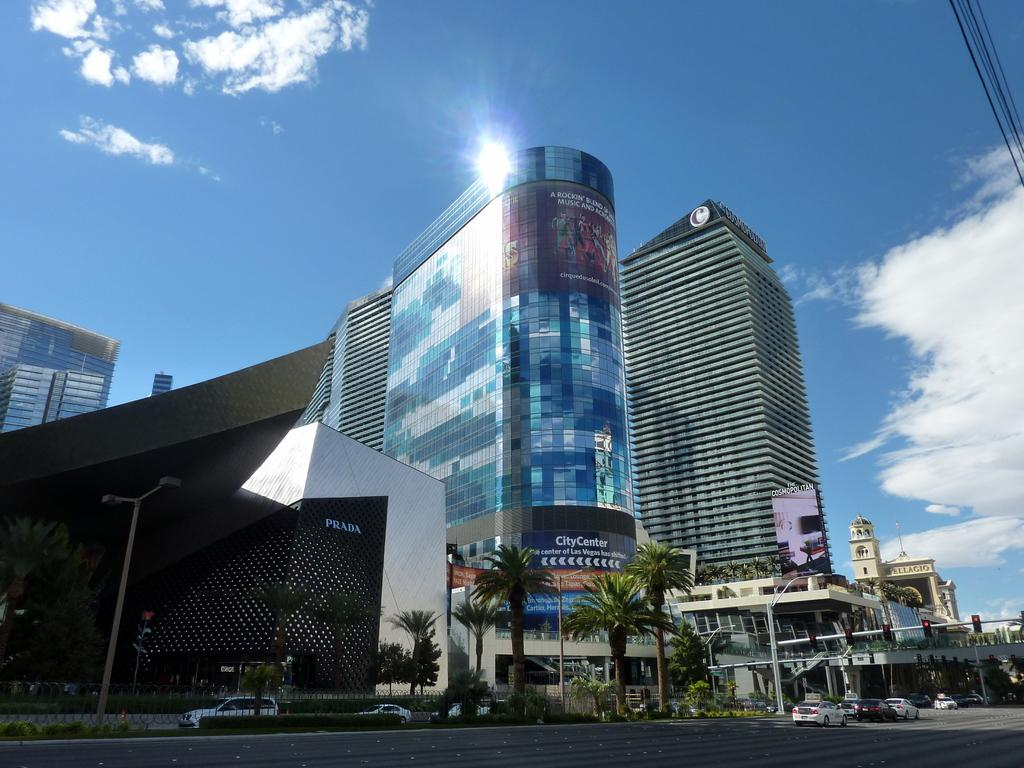<image>
Give a short and clear explanation of the subsequent image. The City Center building has colorful blue tinted windows that reflect the sky. 